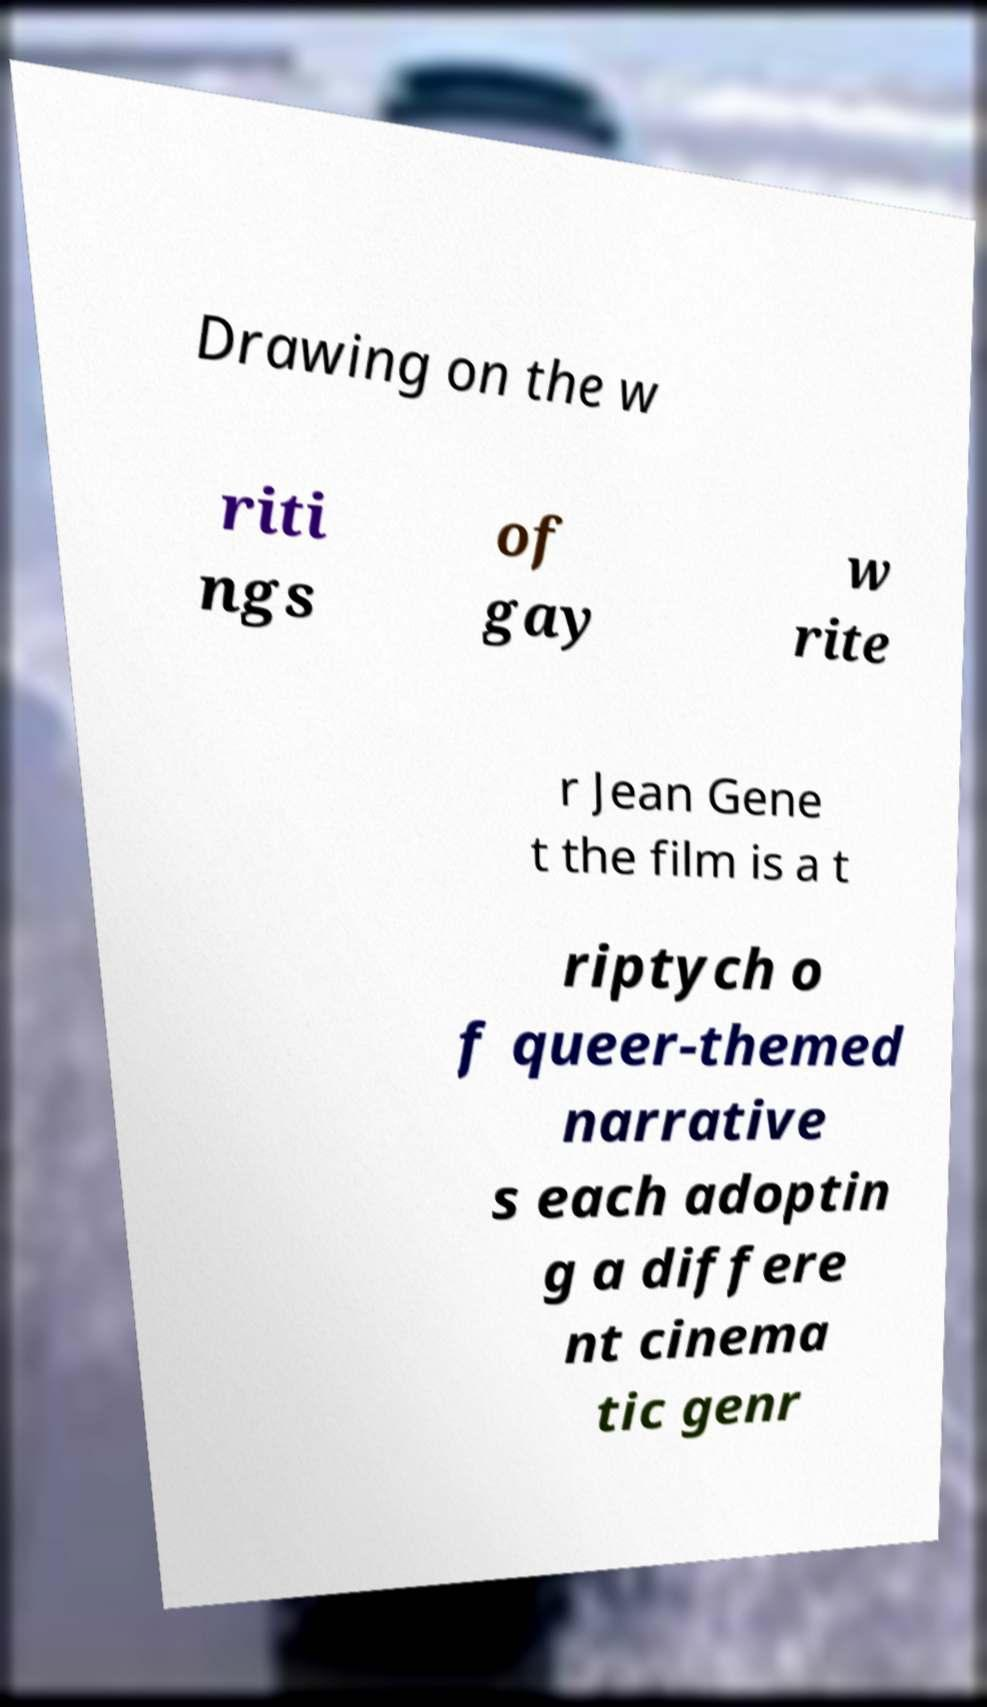There's text embedded in this image that I need extracted. Can you transcribe it verbatim? Drawing on the w riti ngs of gay w rite r Jean Gene t the film is a t riptych o f queer-themed narrative s each adoptin g a differe nt cinema tic genr 